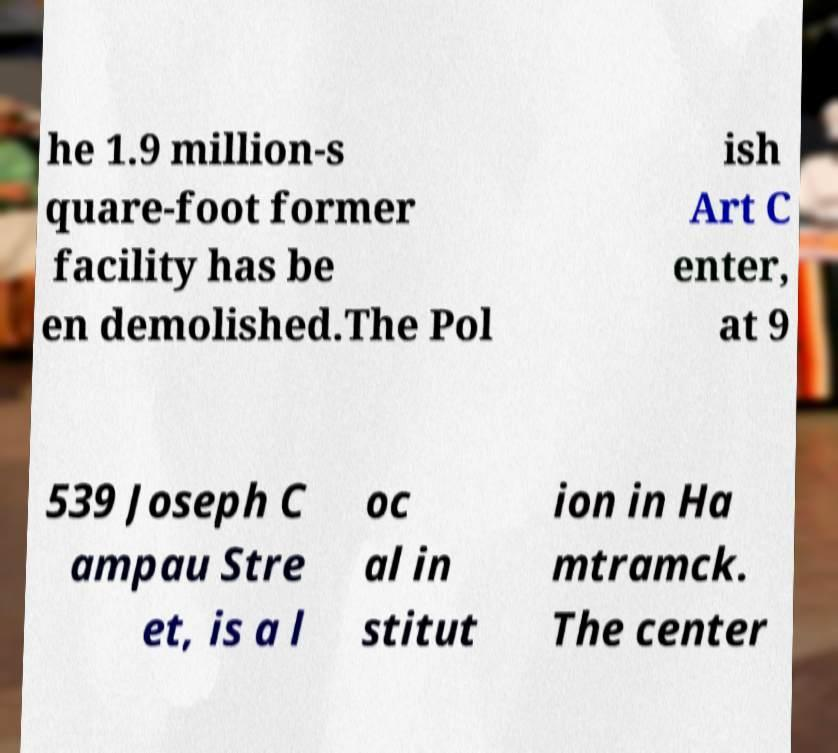What messages or text are displayed in this image? I need them in a readable, typed format. he 1.9 million-s quare-foot former facility has be en demolished.The Pol ish Art C enter, at 9 539 Joseph C ampau Stre et, is a l oc al in stitut ion in Ha mtramck. The center 